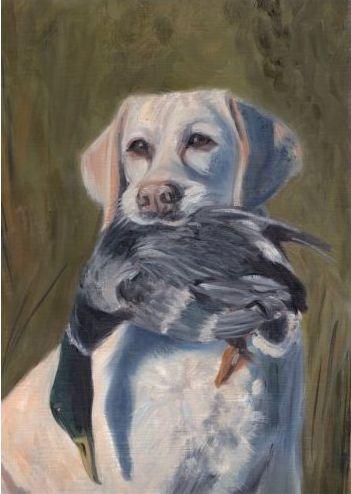Is this a painting?
Concise answer only. Yes. What kind of duck is the dog holding?
Be succinct. Mallard. Is the dog wearing a collar?
Concise answer only. No. What color is the dog?
Write a very short answer. White. Could this dog be a retriever?
Be succinct. Yes. Is the dog playing?
Quick response, please. No. What color fur is the dog?
Short answer required. White. 